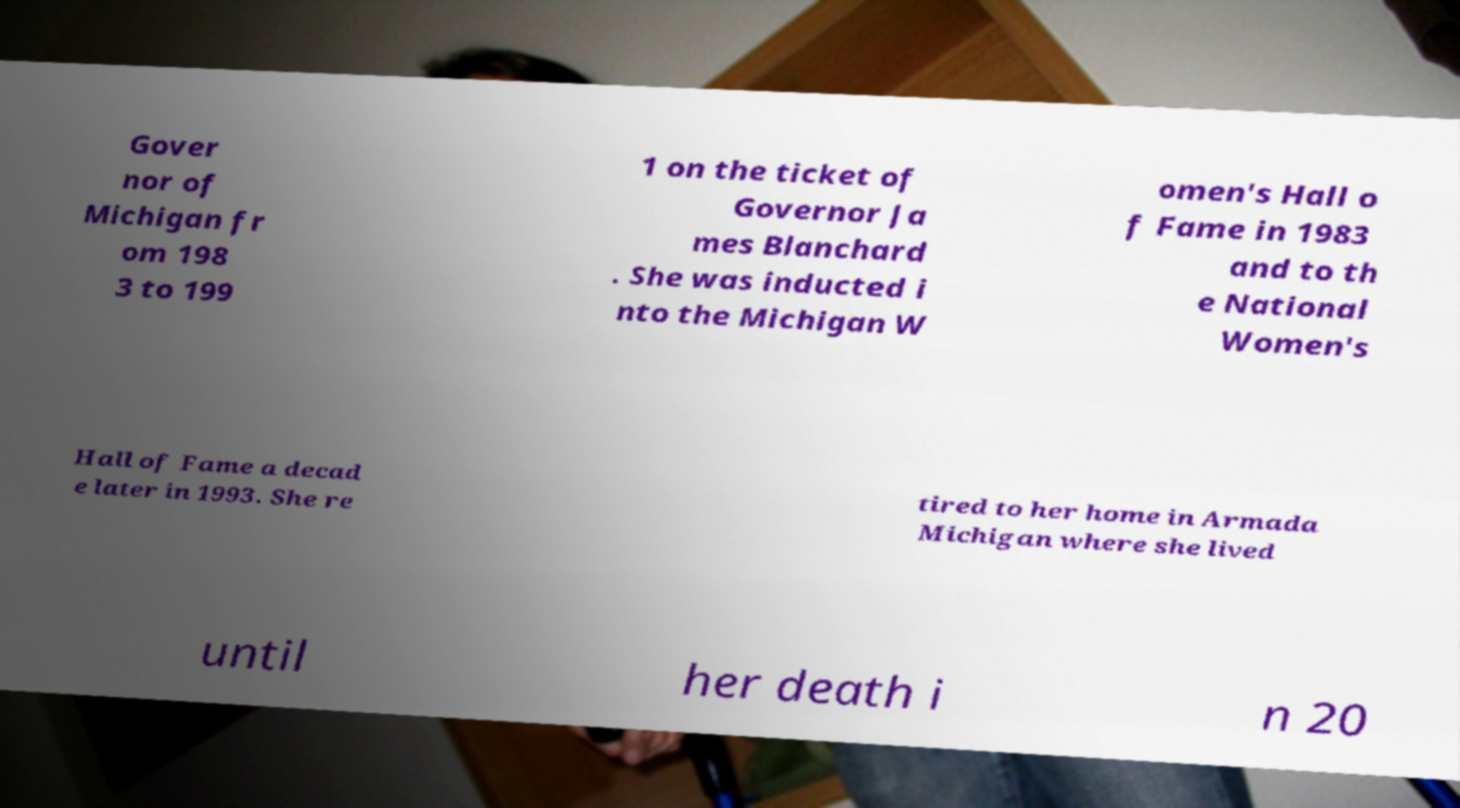I need the written content from this picture converted into text. Can you do that? Gover nor of Michigan fr om 198 3 to 199 1 on the ticket of Governor Ja mes Blanchard . She was inducted i nto the Michigan W omen's Hall o f Fame in 1983 and to th e National Women's Hall of Fame a decad e later in 1993. She re tired to her home in Armada Michigan where she lived until her death i n 20 